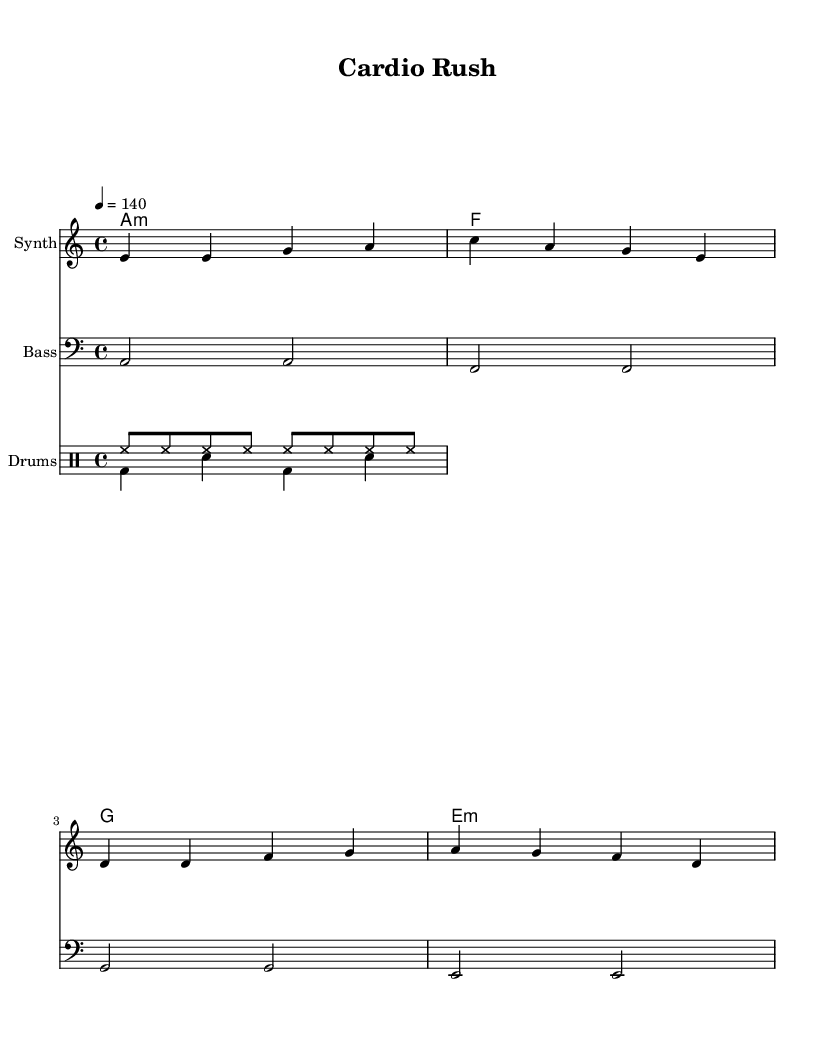What is the key signature of this music? The key signature is A minor, which has no sharps or flats. A minor is the relative minor of C major.
Answer: A minor What is the time signature of this music? The time signature is indicated next to the clef and shows that there are four beats in each measure. This is recognized as 4/4, which is a common time signature.
Answer: 4/4 What is the tempo marking of this music? The tempo marking is indicated by the number following "tempo" and shows that the piece is to be played at 140 beats per minute. This provides a fast, energetic pace suitable for high-intensity workouts.
Answer: 140 How many measures are in the melody? The melody consists of four measures. This can be counted by observing the pattern and structure, which consists of four distinct groupings of notes.
Answer: 4 Identify the type of chords used in the harmonies. The chord progression includes minor and major chords, specifically an A minor, F major, G major, and E minor chord, creating a varied harmonic texture. These are identified by the specific chord names listed.
Answer: Minor and major What is the instrument designation for the melody? The melody is designated for the "Synth", as indicated on the staff where the melody is written. This instrument is commonly used in electronic dance music to produce bright and energetic sounds.
Answer: Synth What is the predominant drum pattern shown in the drum staff? The predominant drum pattern consists of a hi-hat played in eighth notes and a bass drum-snare drum pattern, creating a driving rhythm typical in dance music. This pattern establishes a strong beat for the dance genre.
Answer: Hi-hat and bass-snare pattern 